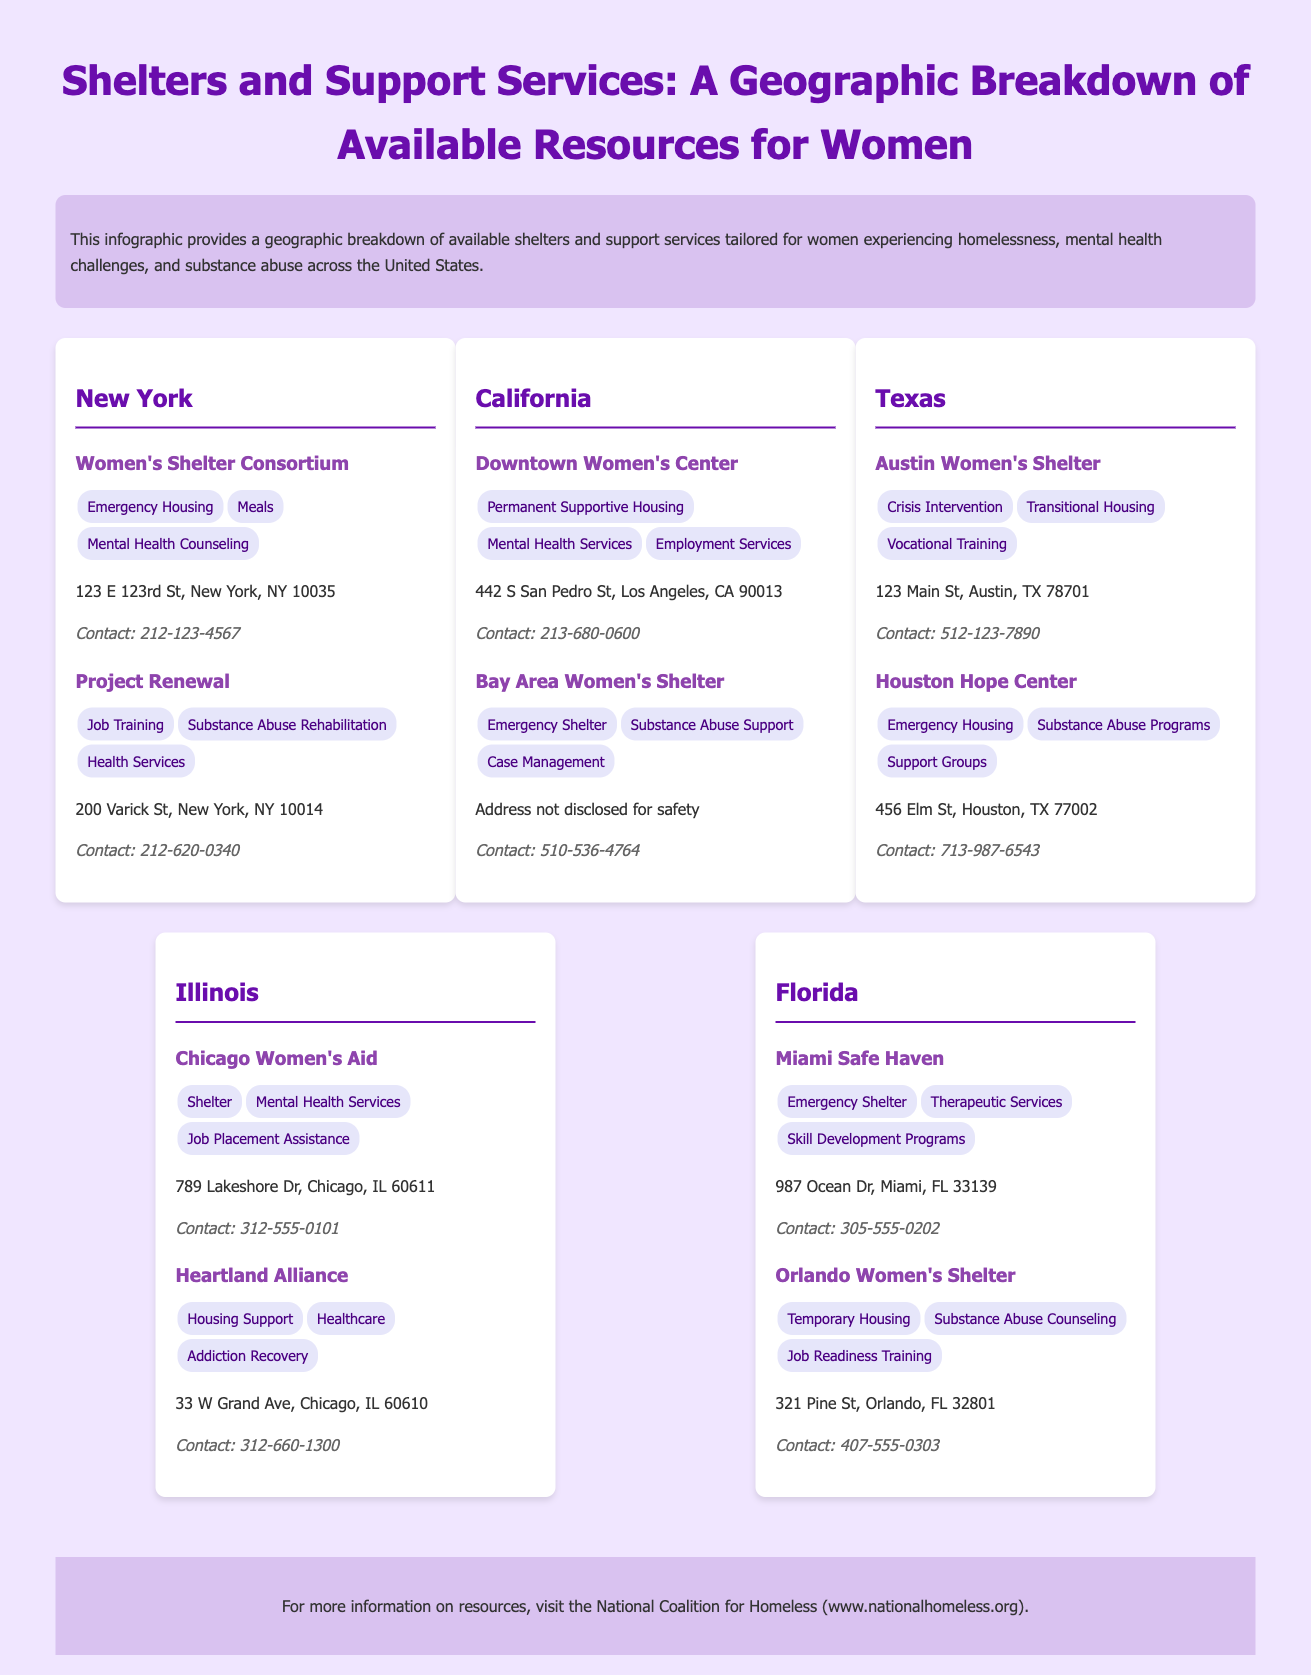what is the name of the shelter in New York that offers mental health counseling? The shelter in New York that offers mental health counseling is the Women's Shelter Consortium.
Answer: Women's Shelter Consortium how many shelters are listed for California? The infographic lists two shelters for California.
Answer: 2 which service is provided by the Houston Hope Center? The Houston Hope Center provides emergency housing as one of its services.
Answer: Emergency Housing what type of housing does the Downtown Women's Center offer? The Downtown Women's Center offers permanent supportive housing.
Answer: Permanent Supportive Housing how many different services does the Orlando Women's Shelter provide? The Orlando Women's Shelter provides three different services: Temporary Housing, Substance Abuse Counseling, and Job Readiness Training.
Answer: 3 which state shows the shelter named "Heartland Alliance"? The shelter named "Heartland Alliance" is located in Illinois.
Answer: Illinois which city is home to the Miami Safe Haven shelter? The Miami Safe Haven shelter is located in Miami.
Answer: Miami what types of services does Project Renewal offer? Project Renewal offers job training, substance abuse rehabilitation, and health services.
Answer: Job Training, Substance Abuse Rehabilitation, Health Services how can one contact the Chicago Women's Aid shelter? One can contact the Chicago Women's Aid shelter at 312-555-0101.
Answer: 312-555-0101 